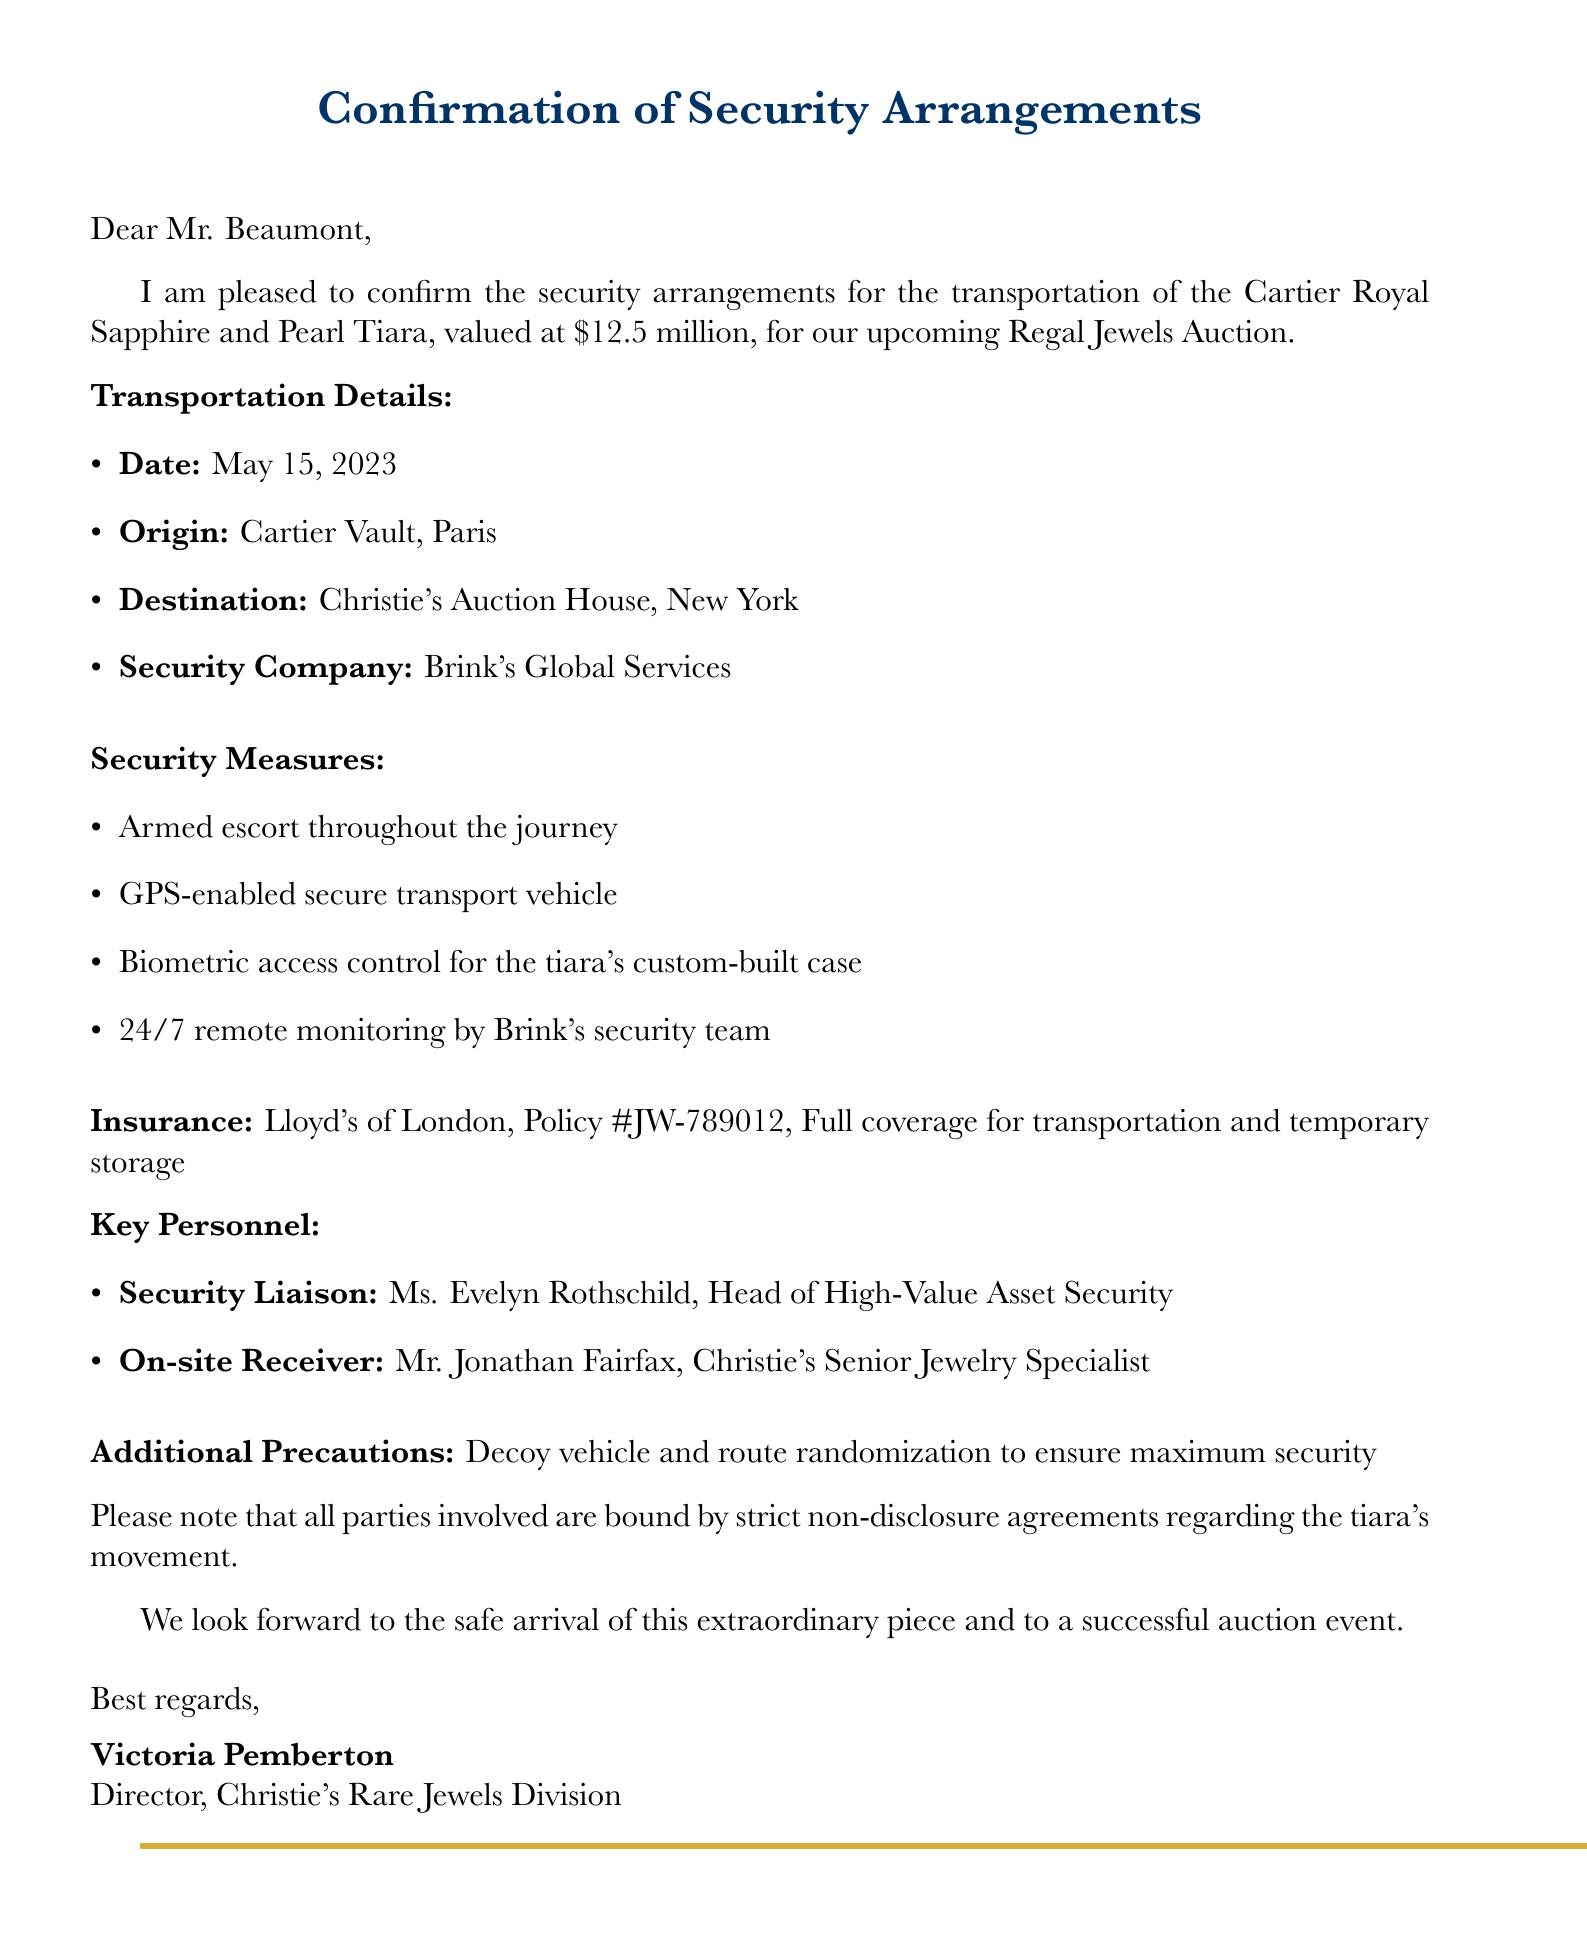What is the tiara's value? The document states the tiara is valued at $12.5 million.
Answer: $12.5 million Who is the security company? The email specifies that the security company is Brink's Global Services.
Answer: Brink's Global Services What is the date of transportation? The document mentions that the transportation date is May 15, 2023.
Answer: May 15, 2023 Who is the on-site receiver? The document indicates that the on-site receiver is Mr. Jonathan Fairfax.
Answer: Mr. Jonathan Fairfax What additional precaution is stated? The email notes the use of a decoy vehicle and route randomization for security.
Answer: Decoy vehicle and route randomization What type of insurance covers the tiara? The document mentions that the tiara is insured under a full coverage policy.
Answer: Full coverage Why is non-disclosure important in this context? The document states that all parties are bound by strict non-disclosure agreements regarding the tiara's movement, highlighting the need for confidentiality in high-value asset transportation.
Answer: Confidentiality What is the origin of the tiara? The email specifies that the tiara's transportation origin is the Cartier Vault in Paris.
Answer: Cartier Vault, Paris Who is the security liaison? The document identifies the security liaison as Ms. Evelyn Rothschild.
Answer: Ms. Evelyn Rothschild 